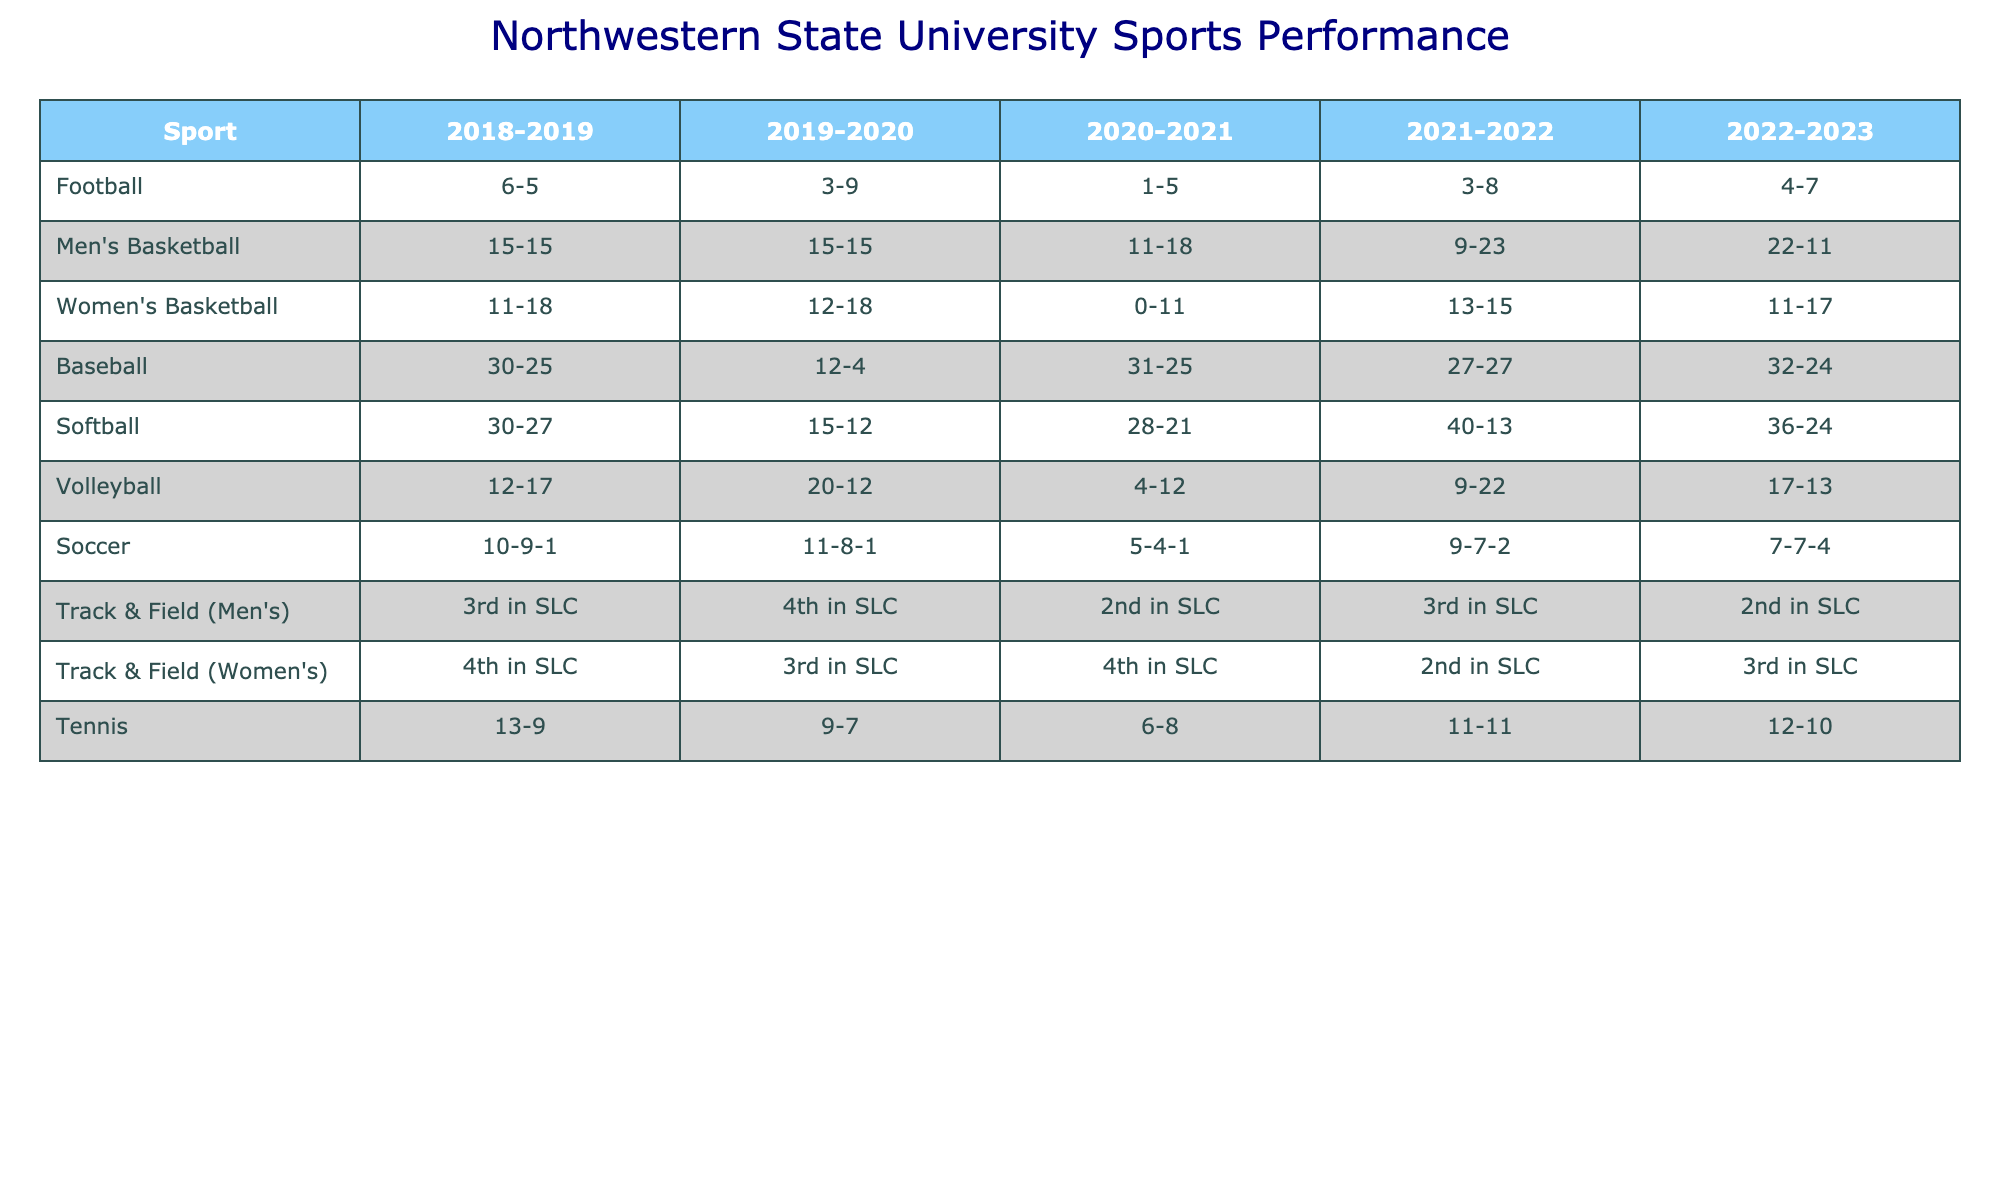What was the football team's best season record over the past five years? The records for the football team are 6-5, 3-9, 1-5, 3-8, and 4-7. The highest winning record is 6-5 from the 2018-2019 season.
Answer: 6-5 Which season did the men's basketball team perform the worst? The men's basketball team had records of 15-15, 15-15, 11-18, 9-23, and 22-11. The lowest record was 9-23 in the 2021-2022 season.
Answer: 2021-2022 What is the average wins in baseball over the past five seasons? The baseball records are 30, 12, 31, 27, and 32 wins in respective seasons. The average is calculated as (30 + 12 + 31 + 27 + 32) / 5 = 26.4.
Answer: 26.4 Did the women's basketball team ever win more than 15 games in a season? The women's basketball records are 11, 12, 0, 13, and 11 wins. None of these seasons show 15 or more wins.
Answer: No In which year did the softball team have the highest winning percentage? The records for softball are 30-27, 15-12, 28-21, 40-13, and 36-24. The 2021-2022 season has the best record of 40-13, which indicates the highest winning percentage.
Answer: 2021-2022 Which women's track and field season had the highest rank? The rankings for women's track are 4th, 3rd, 4th, 2nd, and 3rd. The highest rank was 2nd in the 2021-2022 season.
Answer: 2021-2022 What is the difference in wins between men's basketball and women's basketball in the 2022-2023 season? In the 2022-2023 season, men's basketball had 22 wins, and women's basketball had 11. The difference is 22 - 11 = 11.
Answer: 11 How did the soccer team's performance change from 2018-2019 to 2022-2023? The soccer records are 10-9-1, 11-8-1, 5-4-1, 9-7-2, and 7-7-4. From 2018-2019 to 2022-2023, they improved from a winning record to a near even record, illustrating variability but no consistent improvement.
Answer: Variable performance Which sport had the best performance on average over the past five seasons? Calculating averages across sports: Baseball (26.4), Softball (29.4), Men's Basketball (14.4), Women's Basketball (11.0), Football (3.8). Softball had the highest average wins.
Answer: Softball Was there a season in which the volleyball team had a winning record? The volleyball records are 12-17, 20-12, 4-12, 9-22, and 17-13. The only winning record appears in the 2019-2020 season (20-12).
Answer: Yes, in 2019-2020 